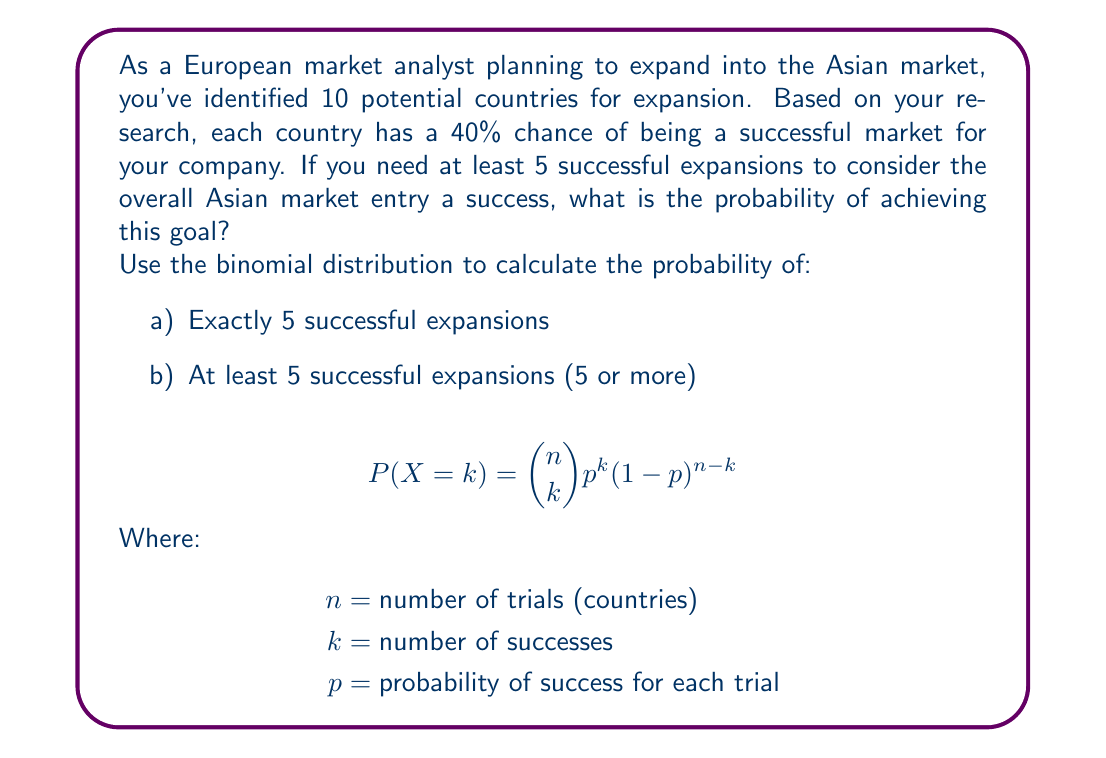Teach me how to tackle this problem. Let's approach this step-by-step using the binomial distribution:

Given:
$n = 10$ (total countries)
$p = 0.4$ (40% chance of success for each country)
$k \geq 5$ (we need at least 5 successful expansions)

Step 1: Calculate the probability of exactly 5 successes
$$P(X = 5) = \binom{10}{5} (0.4)^5 (1-0.4)^{10-5}$$
$$= \binom{10}{5} (0.4)^5 (0.6)^5$$
$$= 252 \times 0.01024 \times 0.07776$$
$$= 0.2001$$

Step 2: Calculate the probability of at least 5 successes
We need to sum the probabilities of 5, 6, 7, 8, 9, and 10 successes:

$$P(X \geq 5) = P(X=5) + P(X=6) + P(X=7) + P(X=8) + P(X=9) + P(X=10)$$

Using the same formula for each:
$$P(X = 6) = \binom{10}{6} (0.4)^6 (0.6)^4 = 0.2001$$
$$P(X = 7) = \binom{10}{7} (0.4)^7 (0.6)^3 = 0.1334$$
$$P(X = 8) = \binom{10}{8} (0.4)^8 (0.6)^2 = 0.0572$$
$$P(X = 9) = \binom{10}{9} (0.4)^9 (0.6)^1 = 0.0127$$
$$P(X = 10) = \binom{10}{10} (0.4)^{10} (0.6)^0 = 0.0010$$

Sum all these probabilities:
$$P(X \geq 5) = 0.2001 + 0.2001 + 0.1334 + 0.0572 + 0.0127 + 0.0010 = 0.6045$$

Therefore, the probability of at least 5 successful expansions is approximately 0.6045 or 60.45%.
Answer: a) P(X = 5) ≈ 0.2001
b) P(X ≥ 5) ≈ 0.6045 